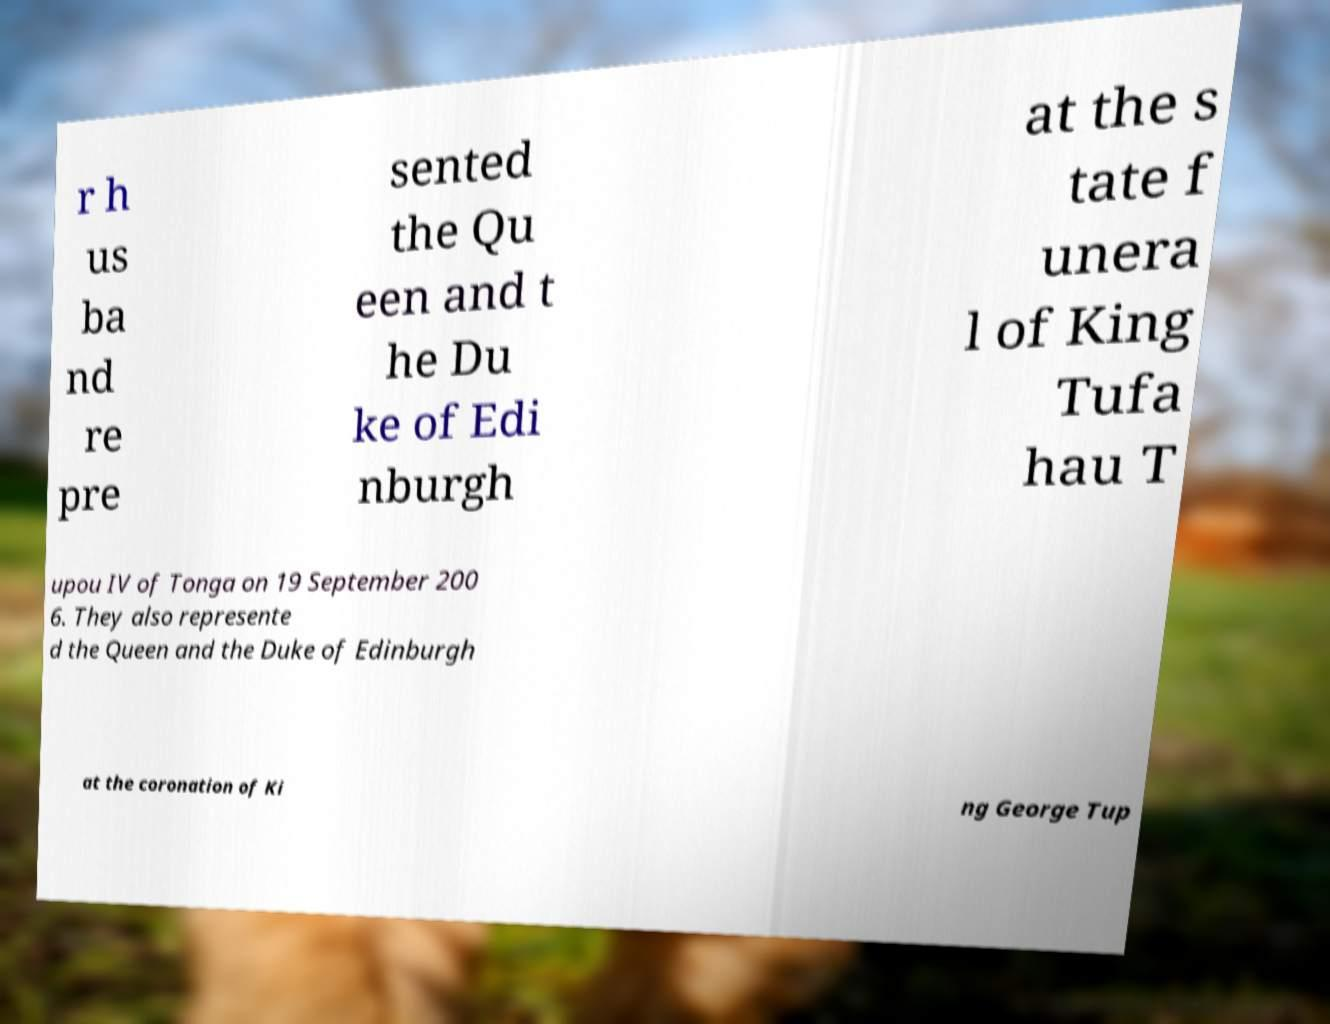Could you extract and type out the text from this image? r h us ba nd re pre sented the Qu een and t he Du ke of Edi nburgh at the s tate f unera l of King Tufa hau T upou IV of Tonga on 19 September 200 6. They also represente d the Queen and the Duke of Edinburgh at the coronation of Ki ng George Tup 